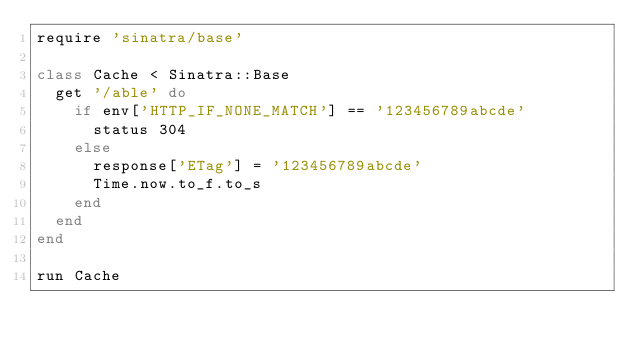Convert code to text. <code><loc_0><loc_0><loc_500><loc_500><_Ruby_>require 'sinatra/base'

class Cache < Sinatra::Base
  get '/able' do
    if env['HTTP_IF_NONE_MATCH'] == '123456789abcde'
      status 304
    else
      response['ETag'] = '123456789abcde'
      Time.now.to_f.to_s
    end
  end
end

run Cache
</code> 